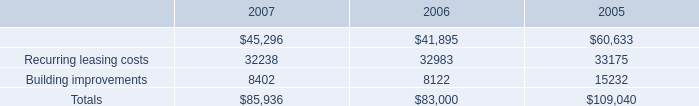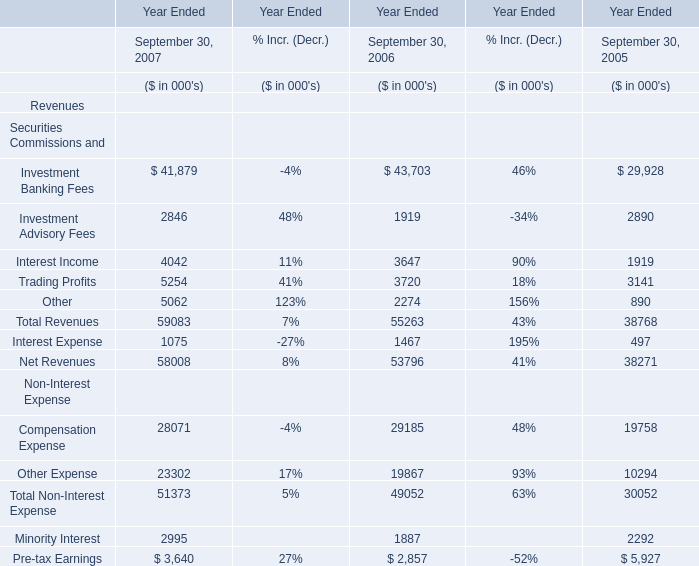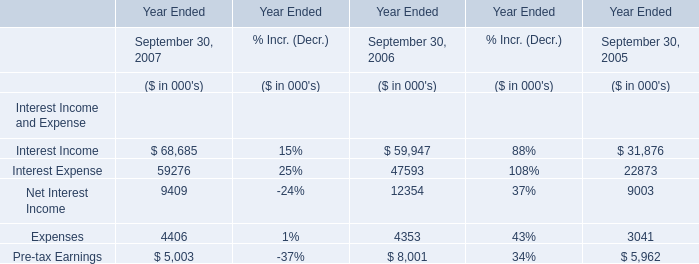What's the sum of all Investment Banking Fees that are positive in 2007 and 2006? 
Computations: (41879 + 43703)
Answer: 85582.0. what was the percent of the increase in the dividends paid per share from 2006 to 2007 
Computations: ((1.91 - 1.89) / 1.89)
Answer: 0.01058. Does Investment Banking Fees keeps increasing each year between 2006 and 2007 ? 
Answer: no. 